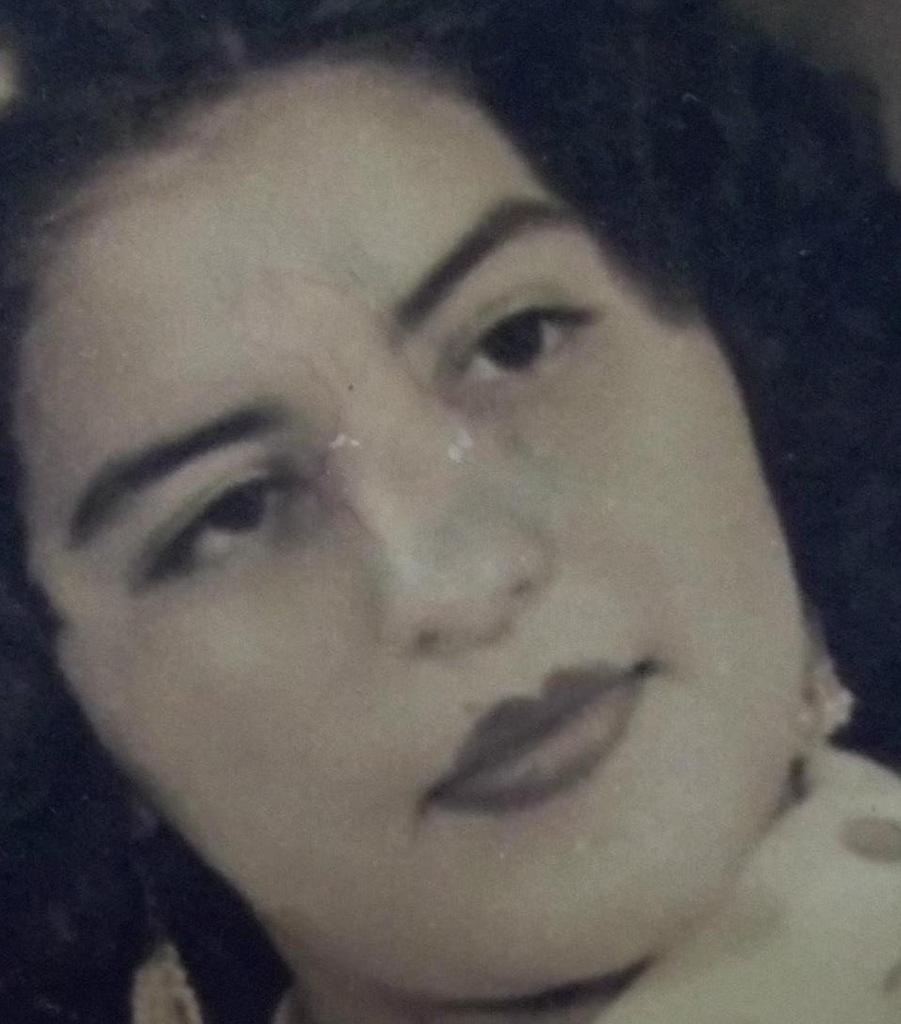What is the main subject of the image? There is a lady in the image. How many times does the lady kiss the canvas in the image? There is no canvas present in the image, and the lady is not kissing anything. 